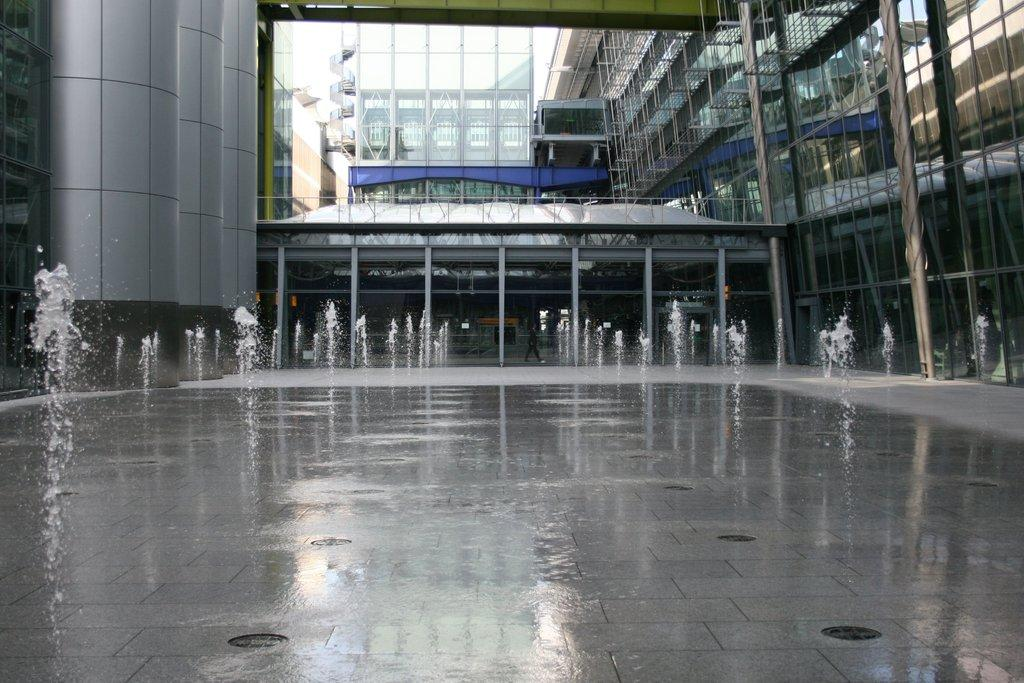What can be seen on the path in the image? There are fountains on the path in the image. What is the person in the image doing? There is a person walking in the image. What can be seen in the distance in the image? There are buildings visible in the background of the image. How much mass does the fountain have in the image? The mass of the fountain cannot be determined from the image alone, as it does not provide any information about the weight or size of the fountain. 